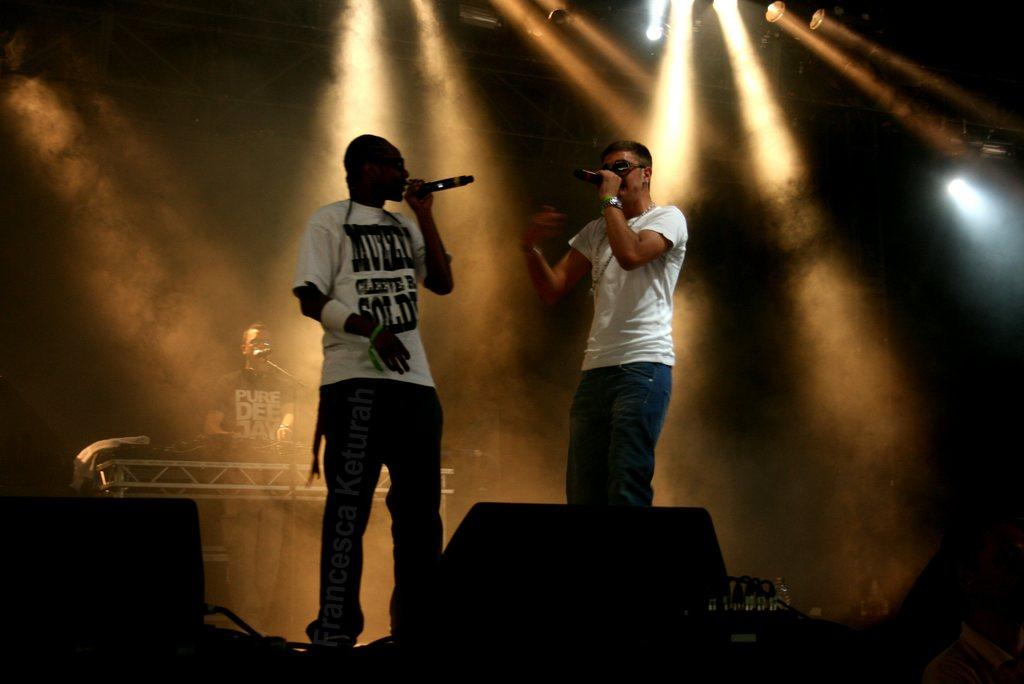How many people are on stage in the image? There are two persons standing on stage in the image. What are the two persons doing on stage? The two persons are singing through a microphone. Can you describe the background of the image? In the background, there is a person playing a musical instrument and show lights are visible. What type of iron can be seen in the image? There is no iron present in the image. How many mint leaves are visible on the stage? There are no mint leaves visible in the image. 